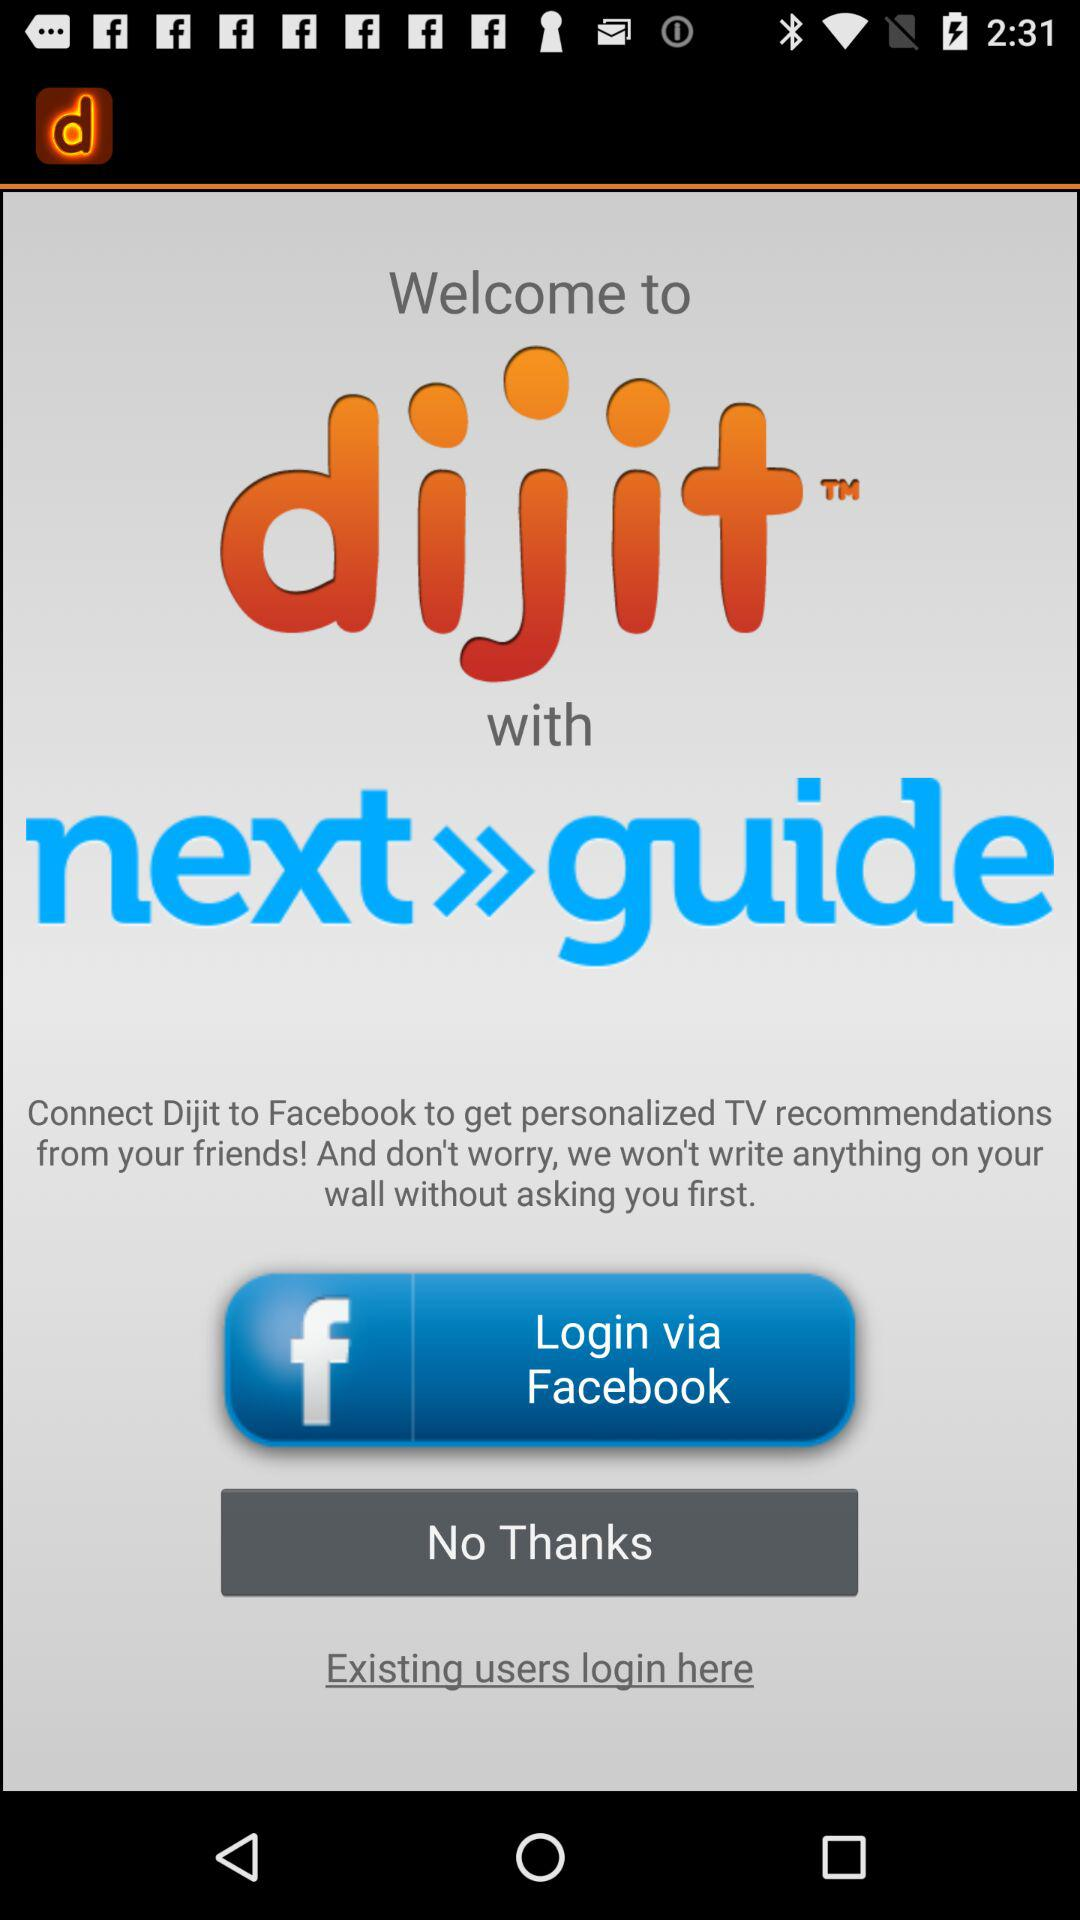What is the name of the application? The name of the application is "dijit". 